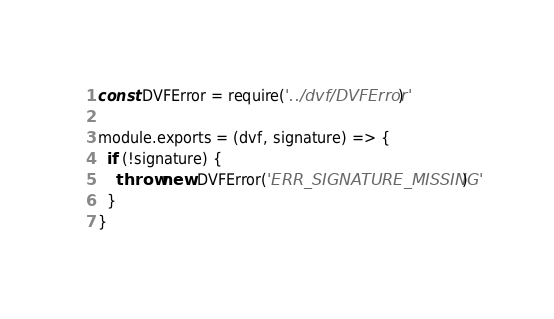Convert code to text. <code><loc_0><loc_0><loc_500><loc_500><_JavaScript_>const DVFError = require('../dvf/DVFError')

module.exports = (dvf, signature) => {
  if (!signature) {
    throw new DVFError('ERR_SIGNATURE_MISSING')
  }
}
</code> 